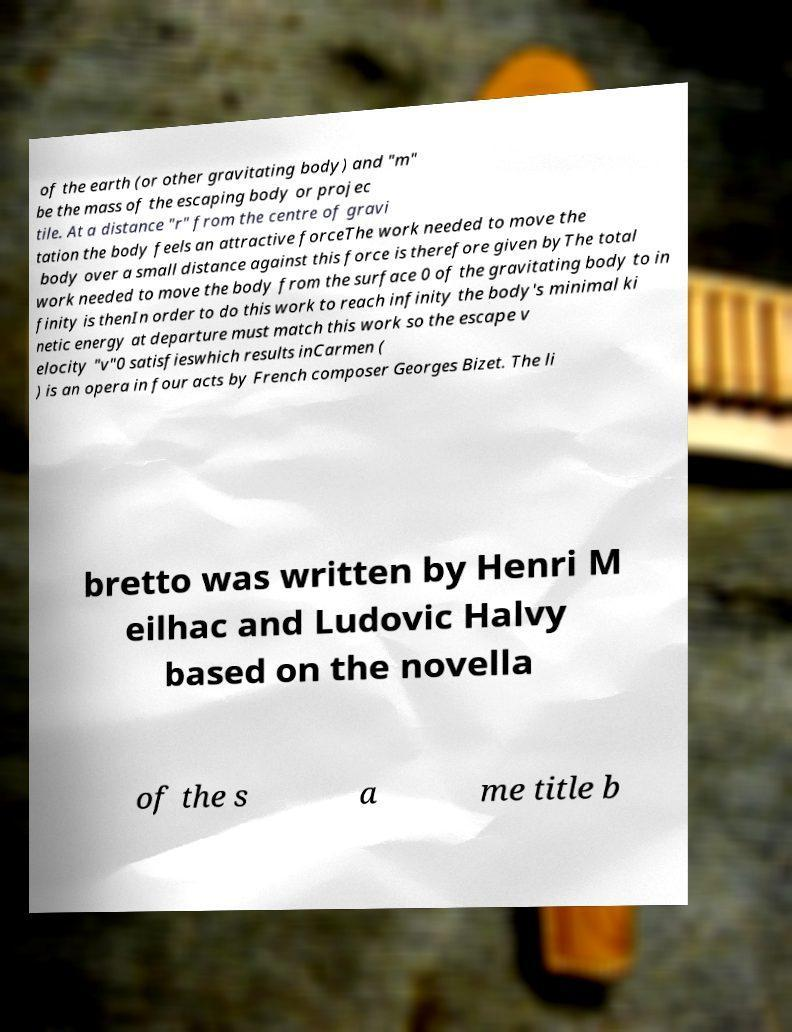Could you assist in decoding the text presented in this image and type it out clearly? of the earth (or other gravitating body) and "m" be the mass of the escaping body or projec tile. At a distance "r" from the centre of gravi tation the body feels an attractive forceThe work needed to move the body over a small distance against this force is therefore given byThe total work needed to move the body from the surface 0 of the gravitating body to in finity is thenIn order to do this work to reach infinity the body's minimal ki netic energy at departure must match this work so the escape v elocity "v"0 satisfieswhich results inCarmen ( ) is an opera in four acts by French composer Georges Bizet. The li bretto was written by Henri M eilhac and Ludovic Halvy based on the novella of the s a me title b 